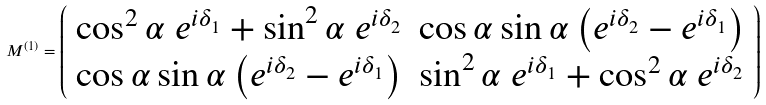Convert formula to latex. <formula><loc_0><loc_0><loc_500><loc_500>M ^ { ( 1 ) } = \left ( \begin{array} { c c } \cos ^ { 2 } \alpha \ e ^ { i \delta _ { 1 } } + \sin ^ { 2 } \alpha \ e ^ { i \delta _ { 2 } } & \cos \alpha \sin \alpha \left ( e ^ { i \delta _ { 2 } } - e ^ { i \delta _ { 1 } } \right ) \\ \cos \alpha \sin \alpha \left ( e ^ { i \delta _ { 2 } } - e ^ { i \delta _ { 1 } } \right ) & \sin ^ { 2 } \alpha \ e ^ { i \delta _ { 1 } } + \cos ^ { 2 } \alpha \ e ^ { i \delta _ { 2 } } \end{array} \right )</formula> 